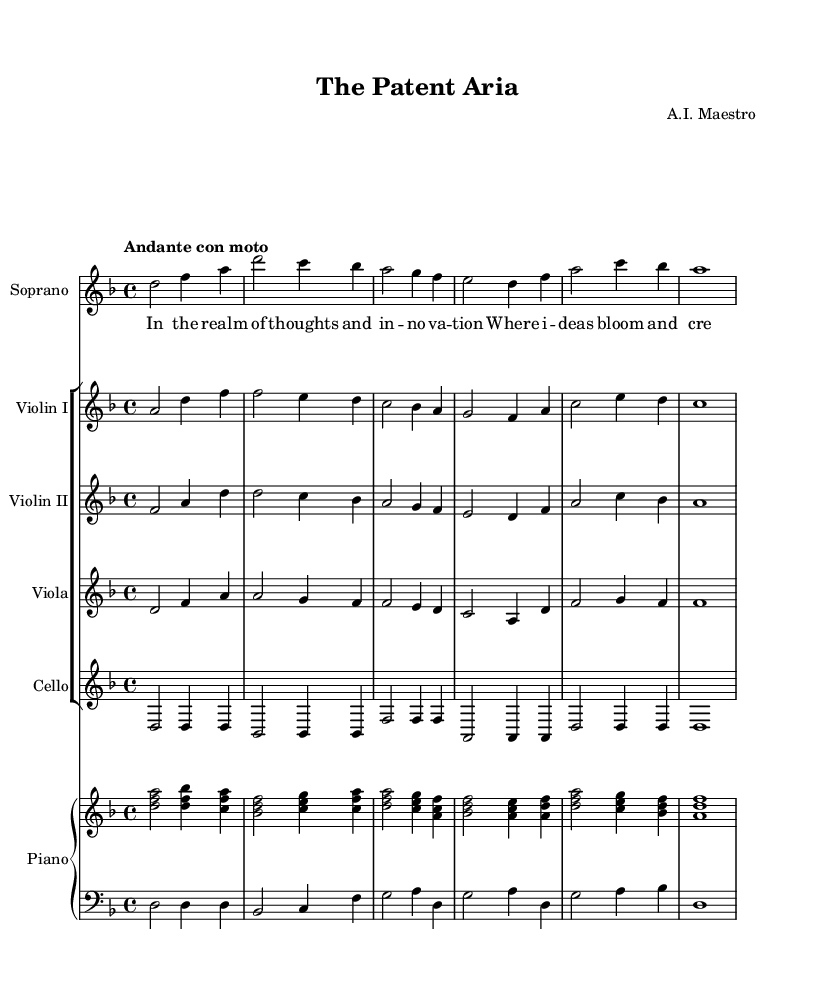What is the key signature of this music? The key signature indicated in the score is D minor, which has one flat (B flat) and is noted at the beginning of the music.
Answer: D minor What is the time signature of this music? The time signature shown in the score is 4/4, meaning there are four beats in a measure and a quarter note receives one beat.
Answer: 4/4 What is the tempo marking of this piece? The tempo marking reads "Andante con moto," which suggests a moderately slow speed with some forward motion.
Answer: Andante con moto What instruments are included in this score? The score lists Soprano, Violin I, Violin II, Viola, Cello, and Piano as the instruments used, which is common in opera ensembles.
Answer: Soprano, Violin I, Violin II, Viola, Cello, Piano Which voice part is prominently featured in the opening? The opening features the Soprano voice, as indicated at the start of this section with the soprano part being sung with lyrics.
Answer: Soprano How many measures are in the soprano voice section shown? The soprano part has six complete measures as visually counted in the music staff from left to right, which includes the notes and rests present.
Answer: Six measures What thematic concept does the lyrics of the soprano voice highlight? The soprano lyrics emphasize "thoughts" and "innovation," focusing on the themes of creativity and artistic expression, which aligns with the opera's exploration of intellectual property rights.
Answer: Creativity and innovation 